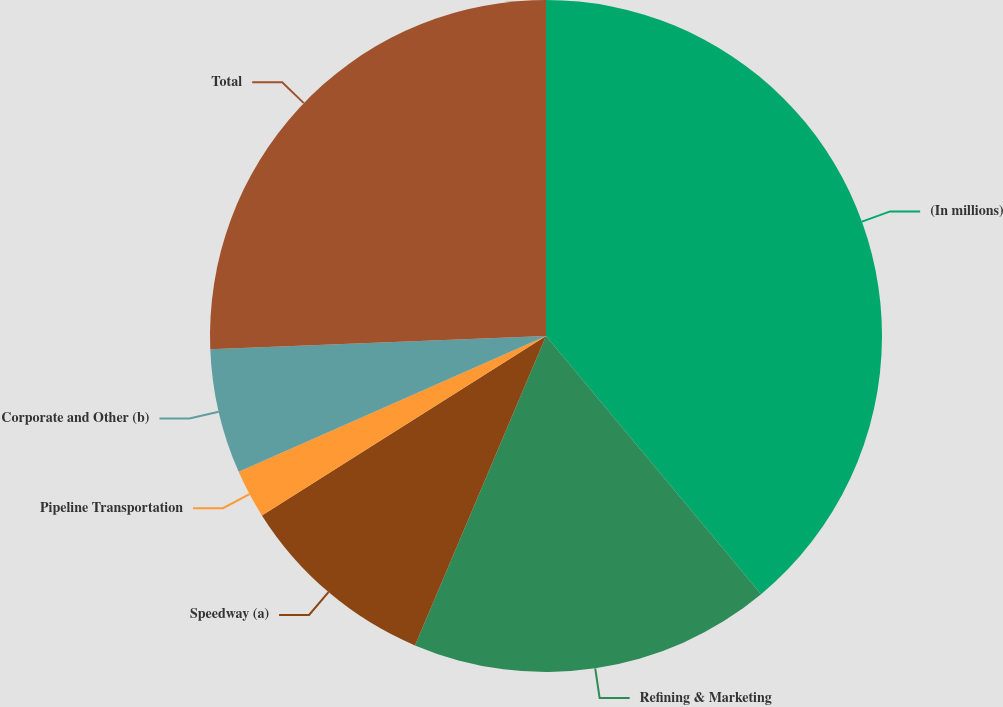Convert chart. <chart><loc_0><loc_0><loc_500><loc_500><pie_chart><fcel>(In millions)<fcel>Refining & Marketing<fcel>Speedway (a)<fcel>Pipeline Transportation<fcel>Corporate and Other (b)<fcel>Total<nl><fcel>38.94%<fcel>17.43%<fcel>9.66%<fcel>2.34%<fcel>6.0%<fcel>25.62%<nl></chart> 